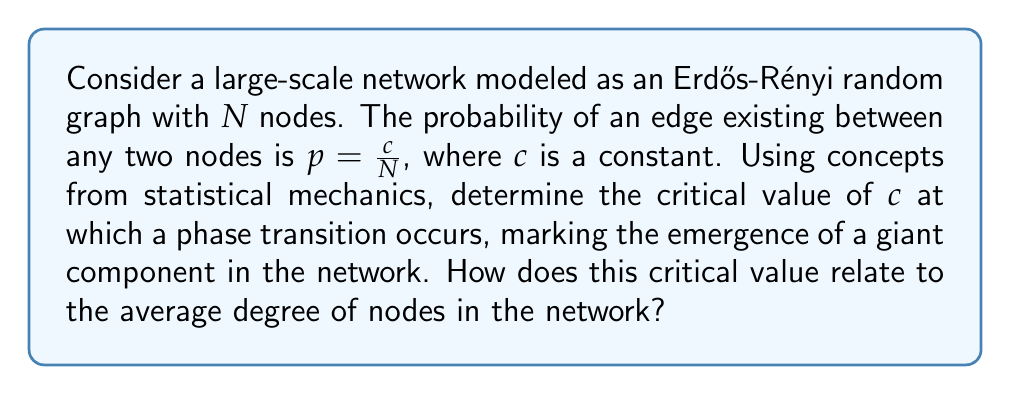Provide a solution to this math problem. To solve this problem, we'll follow these steps:

1) In an Erdős-Rényi random graph, the degree distribution follows a Binomial distribution, which approaches a Poisson distribution for large $N$:

   $$P(k) = e^{-c} \frac{c^k}{k!}$$

   where $k$ is the degree and $c$ is the average degree.

2) The emergence of a giant component in a random graph is analogous to the percolation phase transition in statistical mechanics. This occurs when the average number of secondary connections (excess degree) exceeds 1.

3) The excess degree is given by:

   $$\frac{\langle k^2 \rangle - \langle k \rangle}{\langle k \rangle}$$

   where $\langle k \rangle$ is the average degree and $\langle k^2 \rangle$ is the second moment of the degree distribution.

4) For a Poisson distribution:
   $\langle k \rangle = c$
   $\langle k^2 \rangle = c^2 + c$

5) Substituting into the excess degree formula:

   $$\frac{(c^2 + c) - c}{c} = c$$

6) The phase transition occurs when this equals 1:

   $$c = 1$$

7) Therefore, the critical value of $c$ is 1, which is also equal to the average degree of nodes at the phase transition point.
Answer: $c_{critical} = 1$, equal to the average node degree at the transition. 